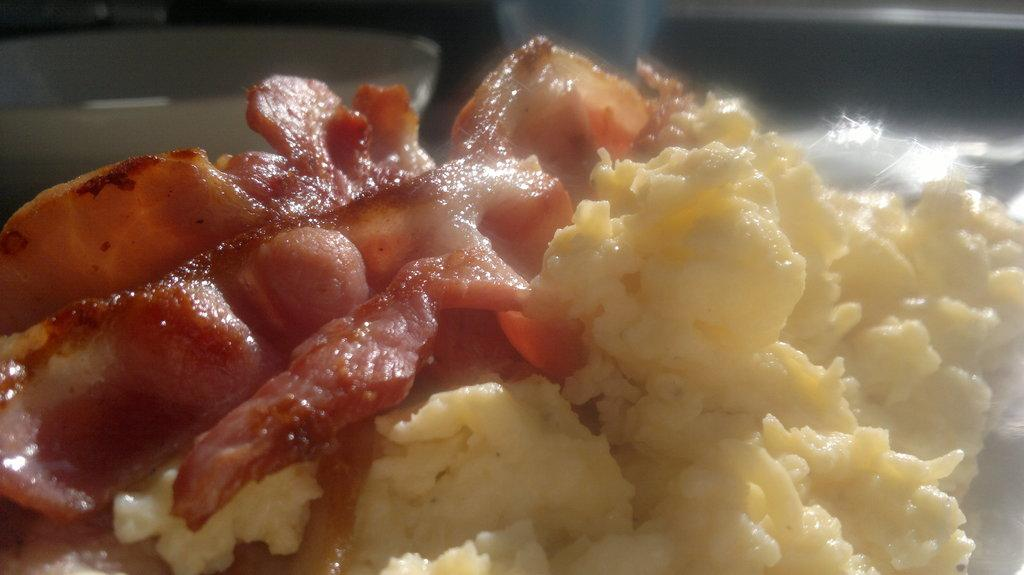What object is visible in the image? There is a bowl in the image. Where is the bowl located in relation to the viewer? The bowl is visible in the front of the image. Can you describe the bowl's position from a different perspective? The bowl is also visible in the back of the image. What type of rail can be seen supporting the bowl in the image? There is no rail present in the image; the bowl is not supported by any rail. 